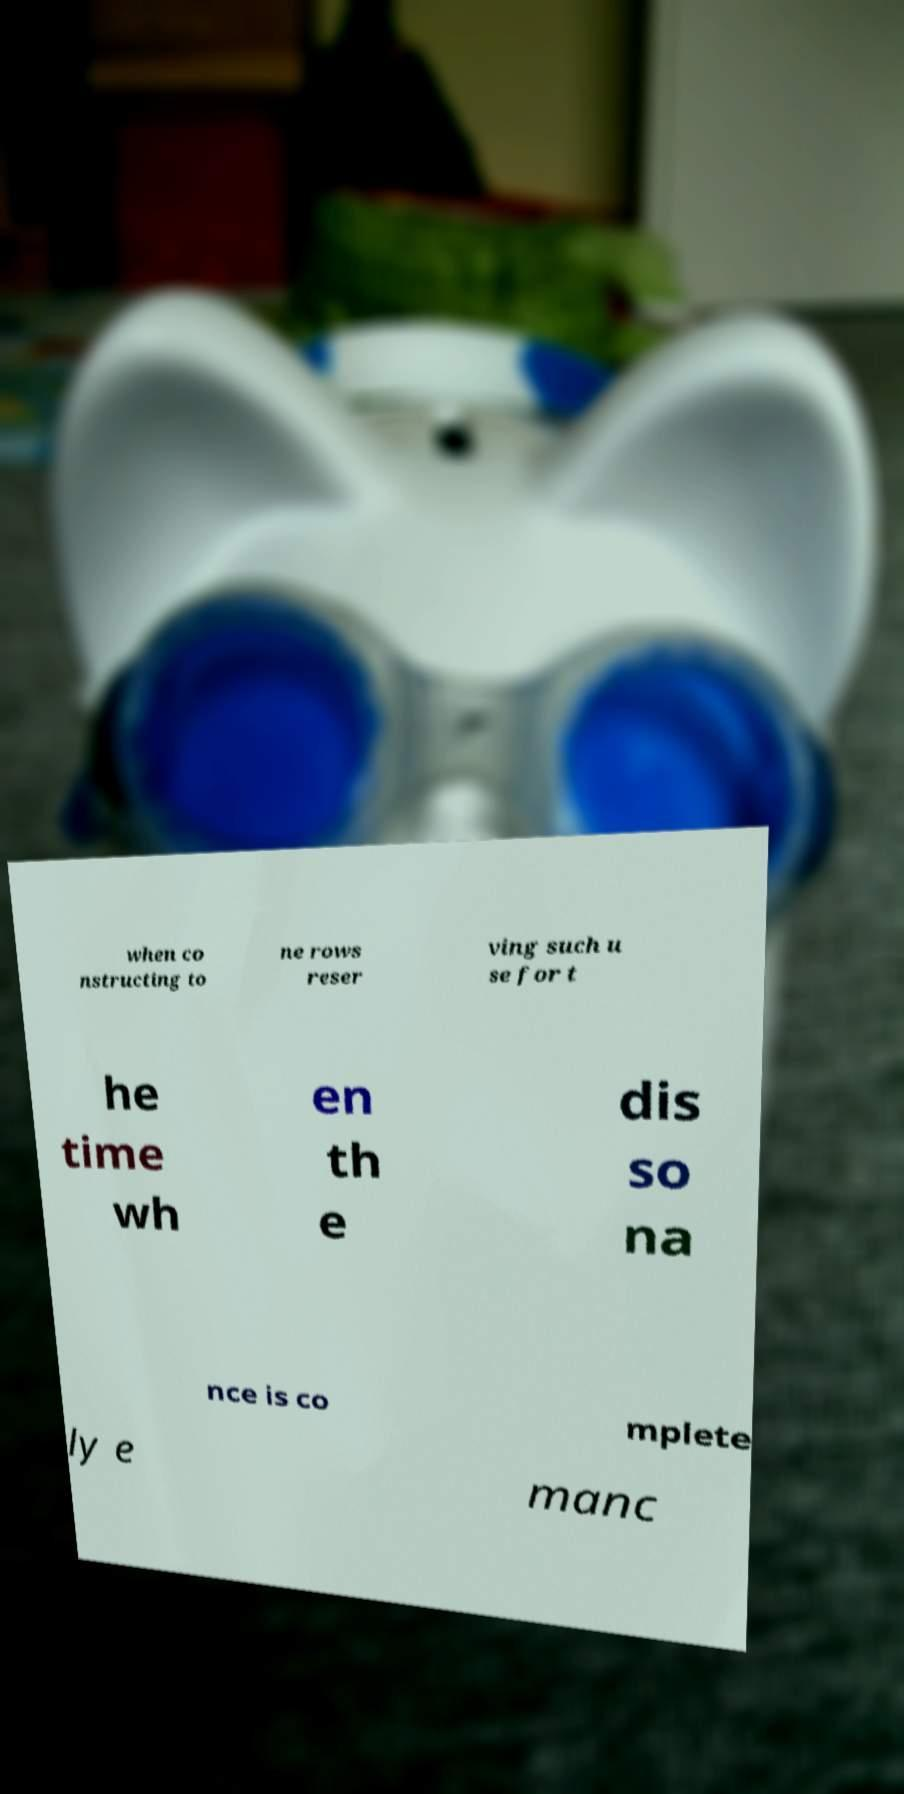What messages or text are displayed in this image? I need them in a readable, typed format. when co nstructing to ne rows reser ving such u se for t he time wh en th e dis so na nce is co mplete ly e manc 